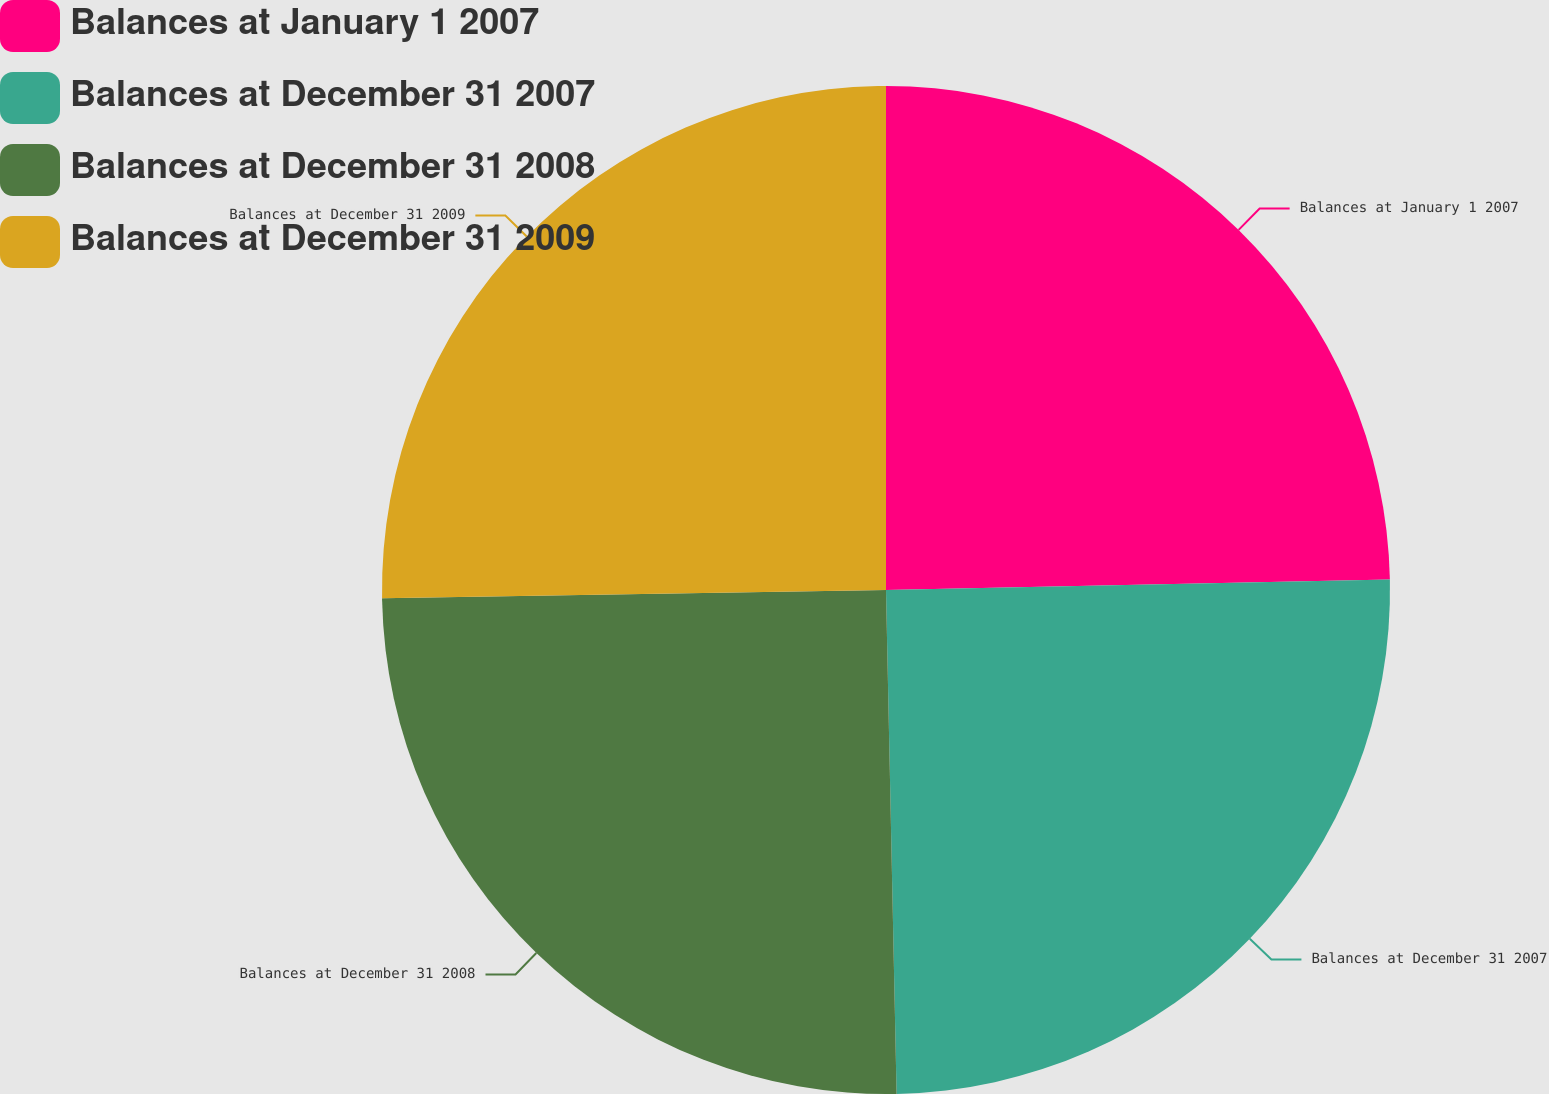Convert chart to OTSL. <chart><loc_0><loc_0><loc_500><loc_500><pie_chart><fcel>Balances at January 1 2007<fcel>Balances at December 31 2007<fcel>Balances at December 31 2008<fcel>Balances at December 31 2009<nl><fcel>24.67%<fcel>25.0%<fcel>25.08%<fcel>25.26%<nl></chart> 